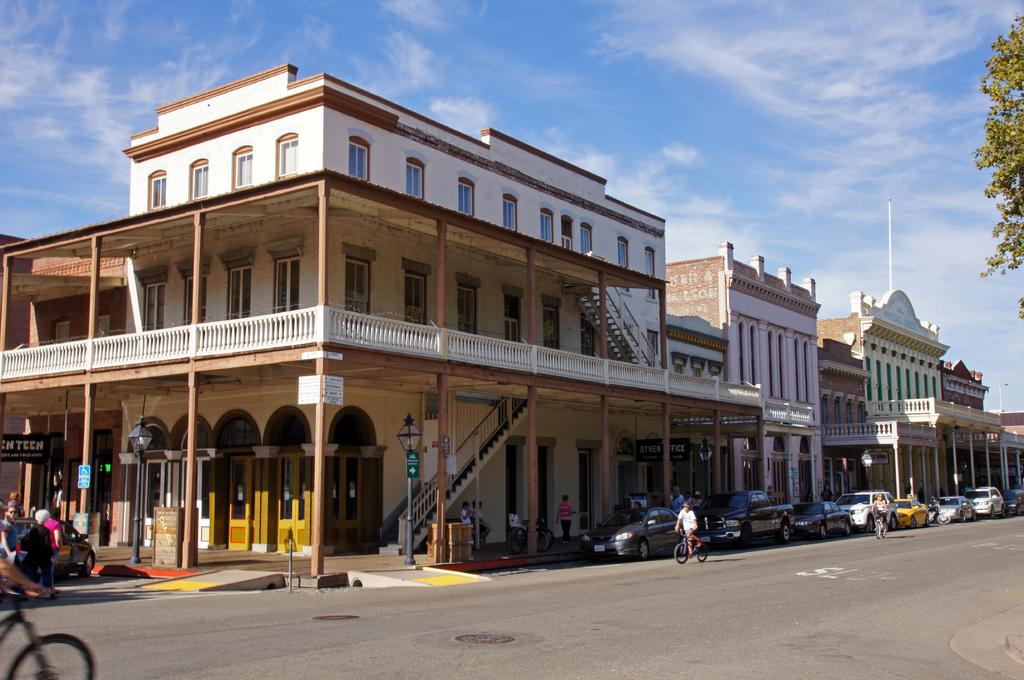What structures are located in the middle of the image? There are buildings in the middle of the image. What can be seen on the right side of the image? There are cars parked on the right side of the image. What type of vegetation is present in the image? There are trees in the image. What color is the sky in the image? The sky is blue in the image. Where is the hose located in the image? There is no hose present in the image. What does the chin of the building look like in the image? There are no specific details about the chin of the building mentioned in the image, as it is not a relevant feature of the buildings shown. 